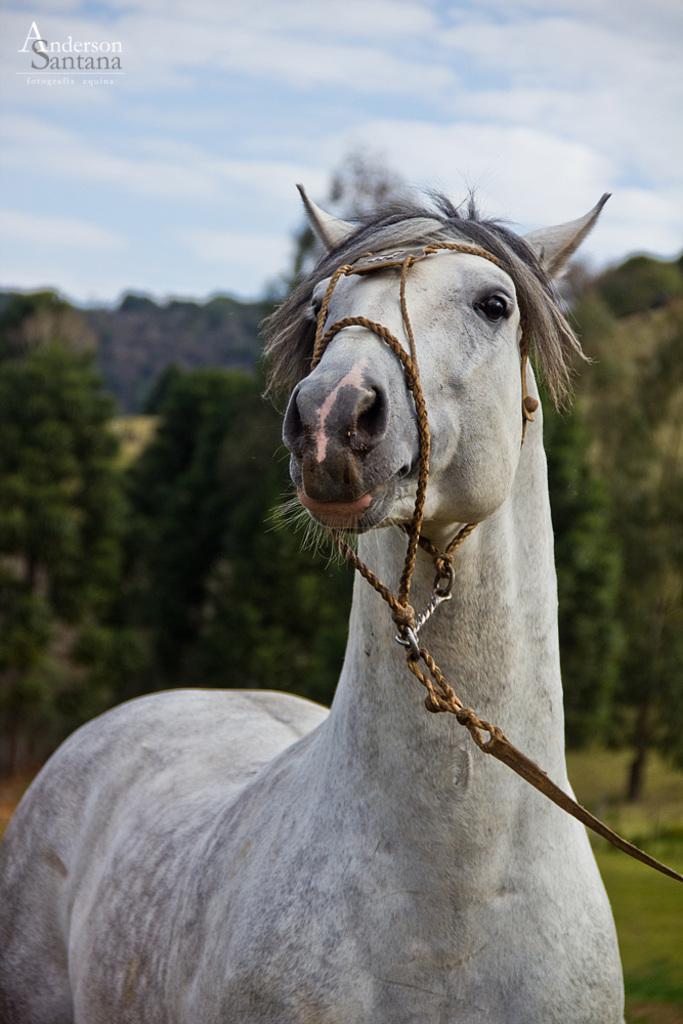Can you describe this image briefly? In this image we can see a horse with the belt. In the background we can see the trees, ground and also the sky with the clouds. We can also see the text. 